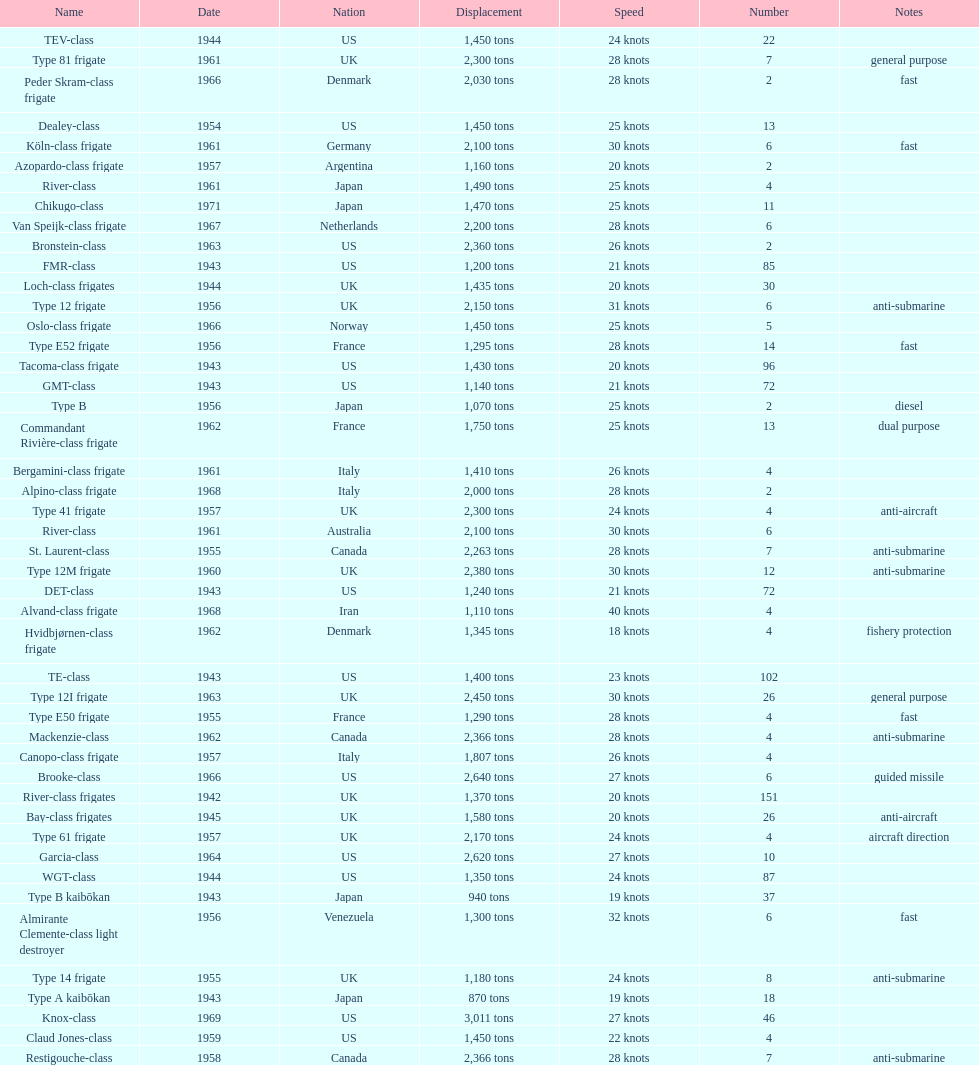How many tons does the te-class displace? 1,400 tons. 